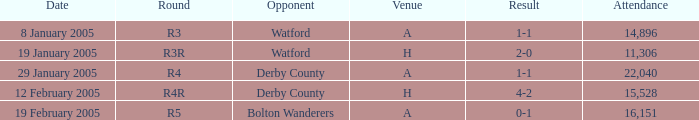What is the stage of the match at location h and adversary of derby county? R4R. 